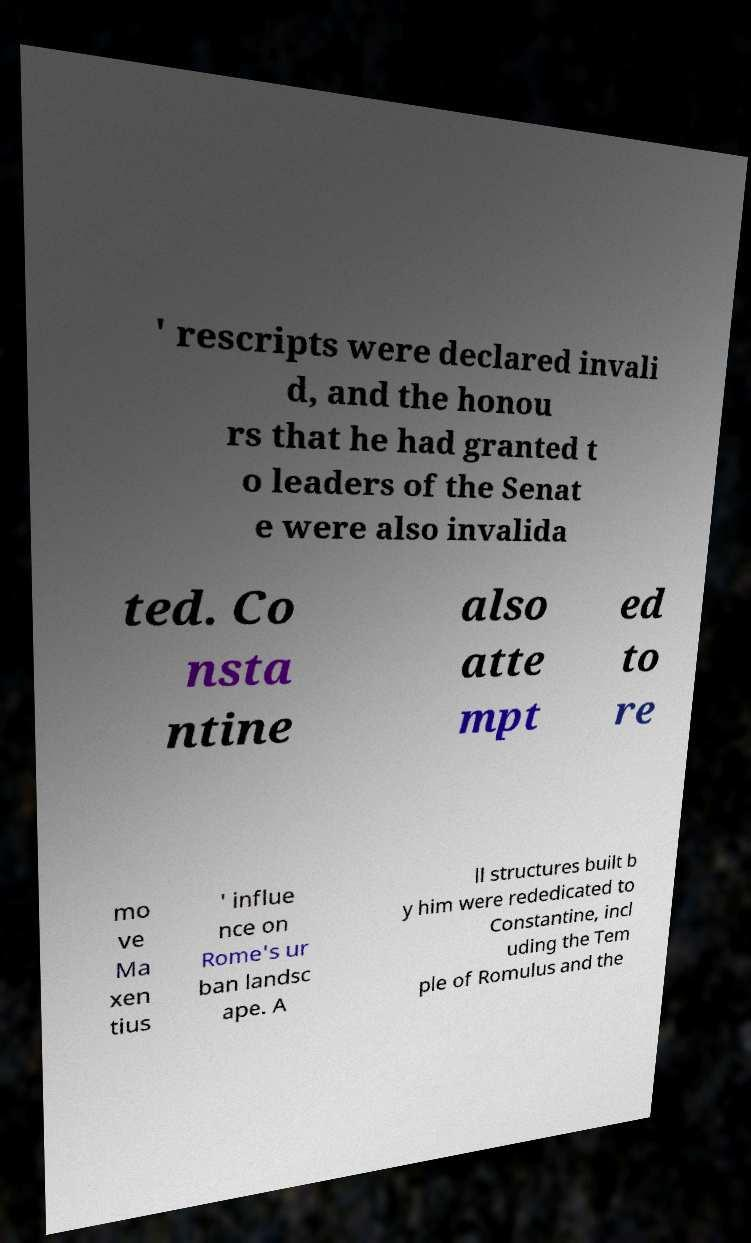For documentation purposes, I need the text within this image transcribed. Could you provide that? ' rescripts were declared invali d, and the honou rs that he had granted t o leaders of the Senat e were also invalida ted. Co nsta ntine also atte mpt ed to re mo ve Ma xen tius ' influe nce on Rome's ur ban landsc ape. A ll structures built b y him were rededicated to Constantine, incl uding the Tem ple of Romulus and the 